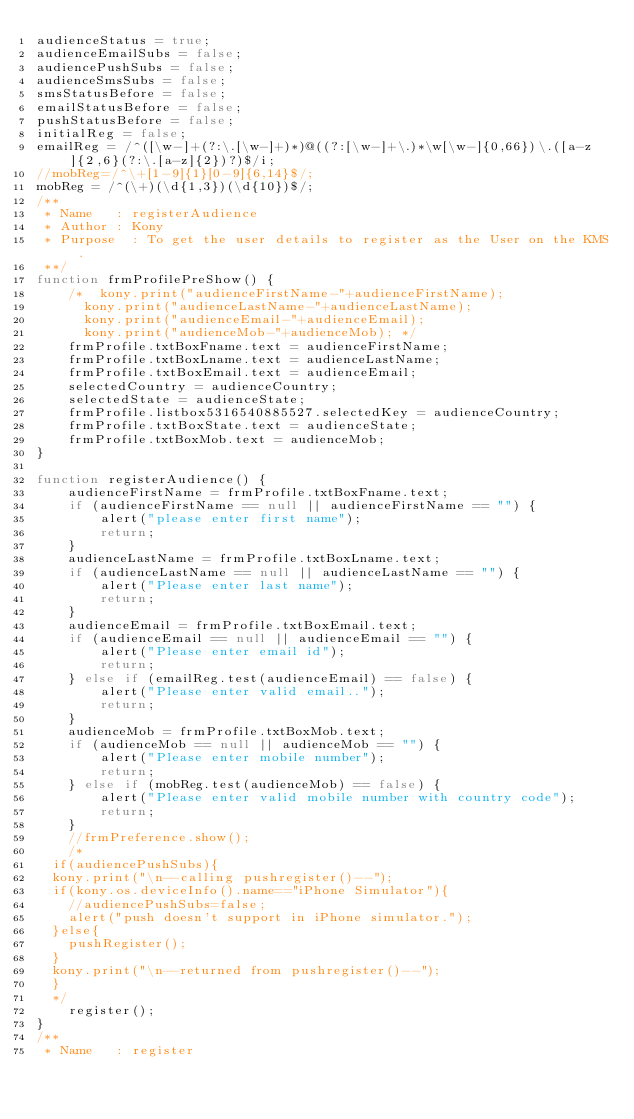<code> <loc_0><loc_0><loc_500><loc_500><_JavaScript_>audienceStatus = true;
audienceEmailSubs = false;
audiencePushSubs = false;
audienceSmsSubs = false;
smsStatusBefore = false;
emailStatusBefore = false;
pushStatusBefore = false;
initialReg = false;
emailReg = /^([\w-]+(?:\.[\w-]+)*)@((?:[\w-]+\.)*\w[\w-]{0,66})\.([a-z]{2,6}(?:\.[a-z]{2})?)$/i;
//mobReg=/^\+[1-9]{1}[0-9]{6,14}$/; 
mobReg = /^(\+)(\d{1,3})(\d{10})$/;
/**
 * Name		:	registerAudience
 * Author	:	Kony
 * Purpose	:	To get the user details to register as the User on the KMS.
 **/
function frmProfilePreShow() {
    /*	kony.print("audienceFirstName-"+audienceFirstName);
    	kony.print("audienceLastName-"+audienceLastName);
    	kony.print("audienceEmail-"+audienceEmail);
    	kony.print("audienceMob-"+audienceMob); */
    frmProfile.txtBoxFname.text = audienceFirstName;
    frmProfile.txtBoxLname.text = audienceLastName;
    frmProfile.txtBoxEmail.text = audienceEmail;
    selectedCountry = audienceCountry;
    selectedState = audienceState;
    frmProfile.listbox5316540885527.selectedKey = audienceCountry;
    frmProfile.txtBoxState.text = audienceState;
    frmProfile.txtBoxMob.text = audienceMob;
}

function registerAudience() {
    audienceFirstName = frmProfile.txtBoxFname.text;
    if (audienceFirstName == null || audienceFirstName == "") {
        alert("please enter first name");
        return;
    }
    audienceLastName = frmProfile.txtBoxLname.text;
    if (audienceLastName == null || audienceLastName == "") {
        alert("Please enter last name");
        return;
    }
    audienceEmail = frmProfile.txtBoxEmail.text;
    if (audienceEmail == null || audienceEmail == "") {
        alert("Please enter email id");
        return;
    } else if (emailReg.test(audienceEmail) == false) {
        alert("Please enter valid email..");
        return;
    }
    audienceMob = frmProfile.txtBoxMob.text;
    if (audienceMob == null || audienceMob == "") {
        alert("Please enter mobile number");
        return;
    } else if (mobReg.test(audienceMob) == false) {
        alert("Please enter valid mobile number with country code");
        return;
    }
    //frmPreference.show();
    /*
	if(audiencePushSubs){
	kony.print("\n--calling pushregister()--");
	if(kony.os.deviceInfo().name=="iPhone Simulator"){
		//audiencePushSubs=false;
		alert("push doesn't support in iPhone simulator.");
	}else{
		pushRegister();
	}
	kony.print("\n--returned from pushregister()--");
	} 
	*/
    register();
}
/**
 * Name		:	register</code> 